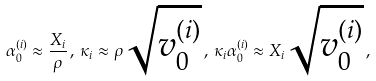Convert formula to latex. <formula><loc_0><loc_0><loc_500><loc_500>\alpha _ { 0 } ^ { ( i ) } \approx \frac { X _ { i } } { \rho } \, , \, \kappa _ { i } \approx \rho \sqrt { v _ { 0 } ^ { ( i ) } } \, , \, \kappa _ { i } \alpha _ { 0 } ^ { ( i ) } \approx X _ { i } \sqrt { v _ { 0 } ^ { ( i ) } } \, ,</formula> 